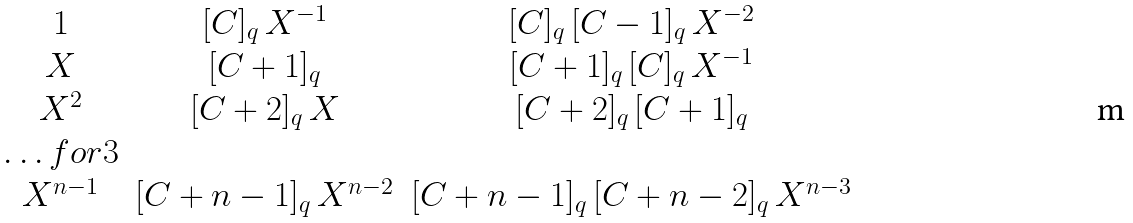<formula> <loc_0><loc_0><loc_500><loc_500>\begin{matrix} 1 & [ C ] _ { q } \, X ^ { - 1 } & [ C ] _ { q } \, [ C - 1 ] _ { q } \, X ^ { - 2 } \\ X & [ C + 1 ] _ { q } & [ C + 1 ] _ { q } \, [ C ] _ { q } \, X ^ { - 1 } \\ X ^ { 2 } & [ C + 2 ] _ { q } \, X & [ C + 2 ] _ { q } \, [ C + 1 ] _ { q } \\ \hdots f o r 3 \\ X ^ { n - 1 } & [ C + n - 1 ] _ { q } \, X ^ { n - 2 } & [ C + n - 1 ] _ { q } \, [ C + n - 2 ] _ { q } \, X ^ { n - 3 } \end{matrix}</formula> 